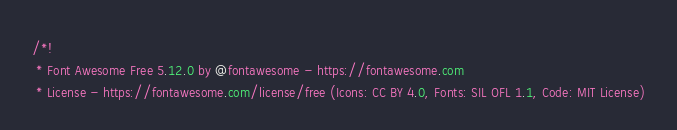Convert code to text. <code><loc_0><loc_0><loc_500><loc_500><_CSS_>/*!
 * Font Awesome Free 5.12.0 by @fontawesome - https://fontawesome.com
 * License - https://fontawesome.com/license/free (Icons: CC BY 4.0, Fonts: SIL OFL 1.1, Code: MIT License)</code> 